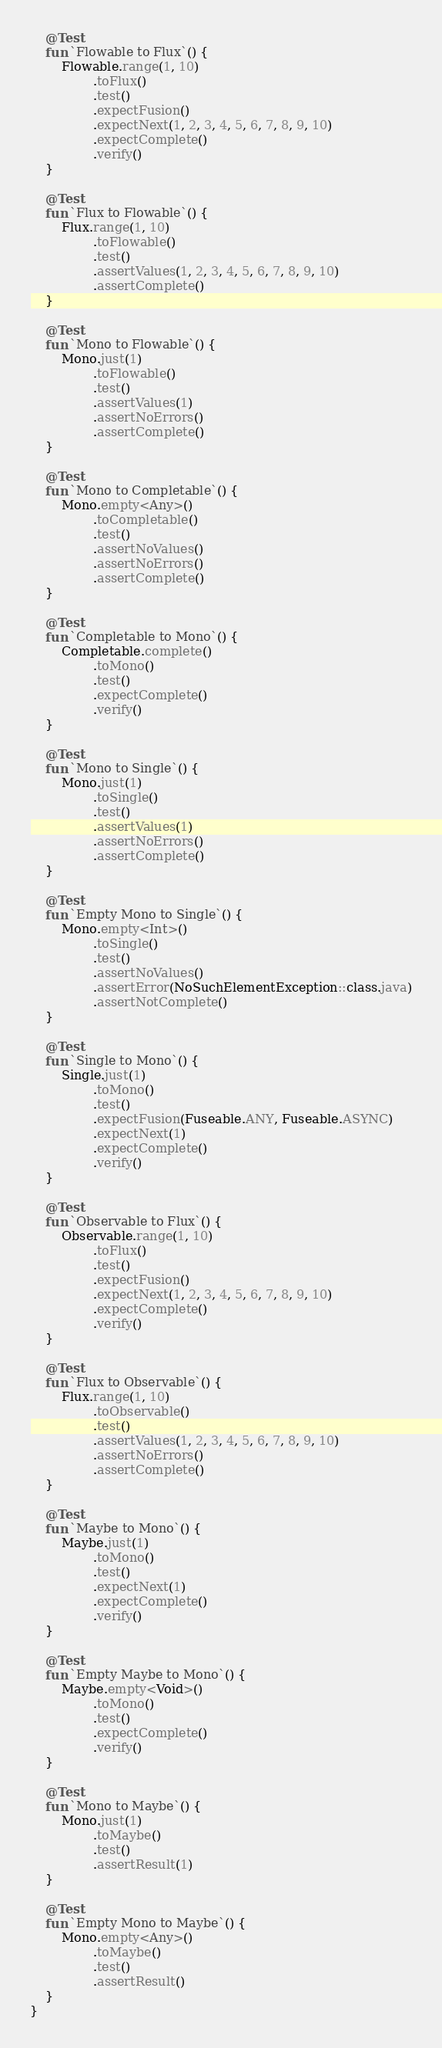Convert code to text. <code><loc_0><loc_0><loc_500><loc_500><_Kotlin_>
    @Test
    fun `Flowable to Flux`() {
        Flowable.range(1, 10)
                .toFlux()
                .test()
                .expectFusion()
                .expectNext(1, 2, 3, 4, 5, 6, 7, 8, 9, 10)
                .expectComplete()
                .verify()
    }

    @Test
    fun `Flux to Flowable`() {
        Flux.range(1, 10)
                .toFlowable()
                .test()
                .assertValues(1, 2, 3, 4, 5, 6, 7, 8, 9, 10)
                .assertComplete()
    }

    @Test
    fun `Mono to Flowable`() {
        Mono.just(1)
                .toFlowable()
                .test()
                .assertValues(1)
                .assertNoErrors()
                .assertComplete()
    }

    @Test
    fun `Mono to Completable`() {
        Mono.empty<Any>()
                .toCompletable()
                .test()
                .assertNoValues()
                .assertNoErrors()
                .assertComplete()
    }

    @Test
    fun `Completable to Mono`() {
        Completable.complete()
                .toMono()
                .test()
                .expectComplete()
                .verify()
    }

    @Test
    fun `Mono to Single`() {
        Mono.just(1)
                .toSingle()
                .test()
                .assertValues(1)
                .assertNoErrors()
                .assertComplete()
    }

    @Test
    fun `Empty Mono to Single`() {
        Mono.empty<Int>()
                .toSingle()
                .test()
                .assertNoValues()
                .assertError(NoSuchElementException::class.java)
                .assertNotComplete()
    }

    @Test
    fun `Single to Mono`() {
        Single.just(1)
                .toMono()
                .test()
                .expectFusion(Fuseable.ANY, Fuseable.ASYNC)
                .expectNext(1)
                .expectComplete()
                .verify()
    }

    @Test
    fun `Observable to Flux`() {
        Observable.range(1, 10)
                .toFlux()
                .test()
                .expectFusion()
                .expectNext(1, 2, 3, 4, 5, 6, 7, 8, 9, 10)
                .expectComplete()
                .verify()
    }

    @Test
    fun `Flux to Observable`() {
        Flux.range(1, 10)
                .toObservable()
                .test()
                .assertValues(1, 2, 3, 4, 5, 6, 7, 8, 9, 10)
                .assertNoErrors()
                .assertComplete()
    }

    @Test
    fun `Maybe to Mono`() {
        Maybe.just(1)
                .toMono()
                .test()
                .expectNext(1)
                .expectComplete()
                .verify()
    }

    @Test
    fun `Empty Maybe to Mono`() {
        Maybe.empty<Void>()
                .toMono()
                .test()
                .expectComplete()
                .verify()
    }

    @Test
    fun `Mono to Maybe`() {
        Mono.just(1)
                .toMaybe()
                .test()
                .assertResult(1)
    }

    @Test
    fun `Empty Mono to Maybe`() {
        Mono.empty<Any>()
                .toMaybe()
                .test()
                .assertResult()
    }
}</code> 